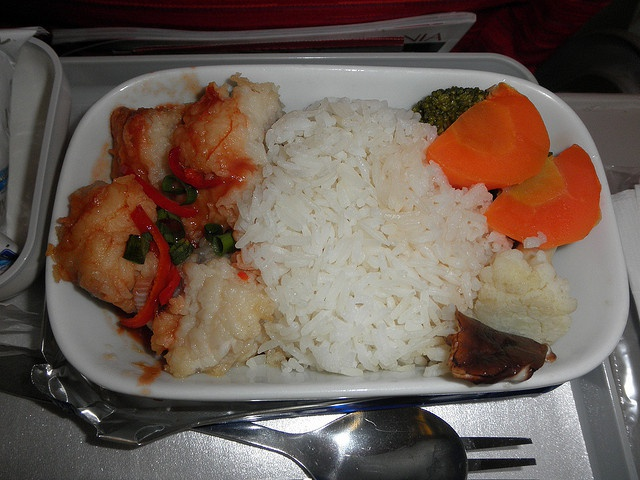Describe the objects in this image and their specific colors. I can see dining table in darkgray, gray, black, and maroon tones, bowl in black, darkgray, maroon, and gray tones, spoon in black, gray, darkgray, and white tones, carrot in black, brown, maroon, and salmon tones, and chair in black and gray tones in this image. 